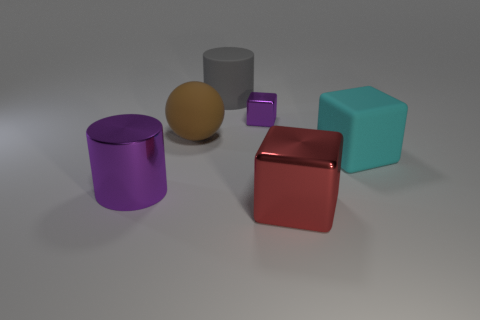Which two shapes appear to have a reflective surface? The cylinder and sphere have reflective surfaces. They seem to be made of similar materials that reflect the light, giving them a shiny appearance. 